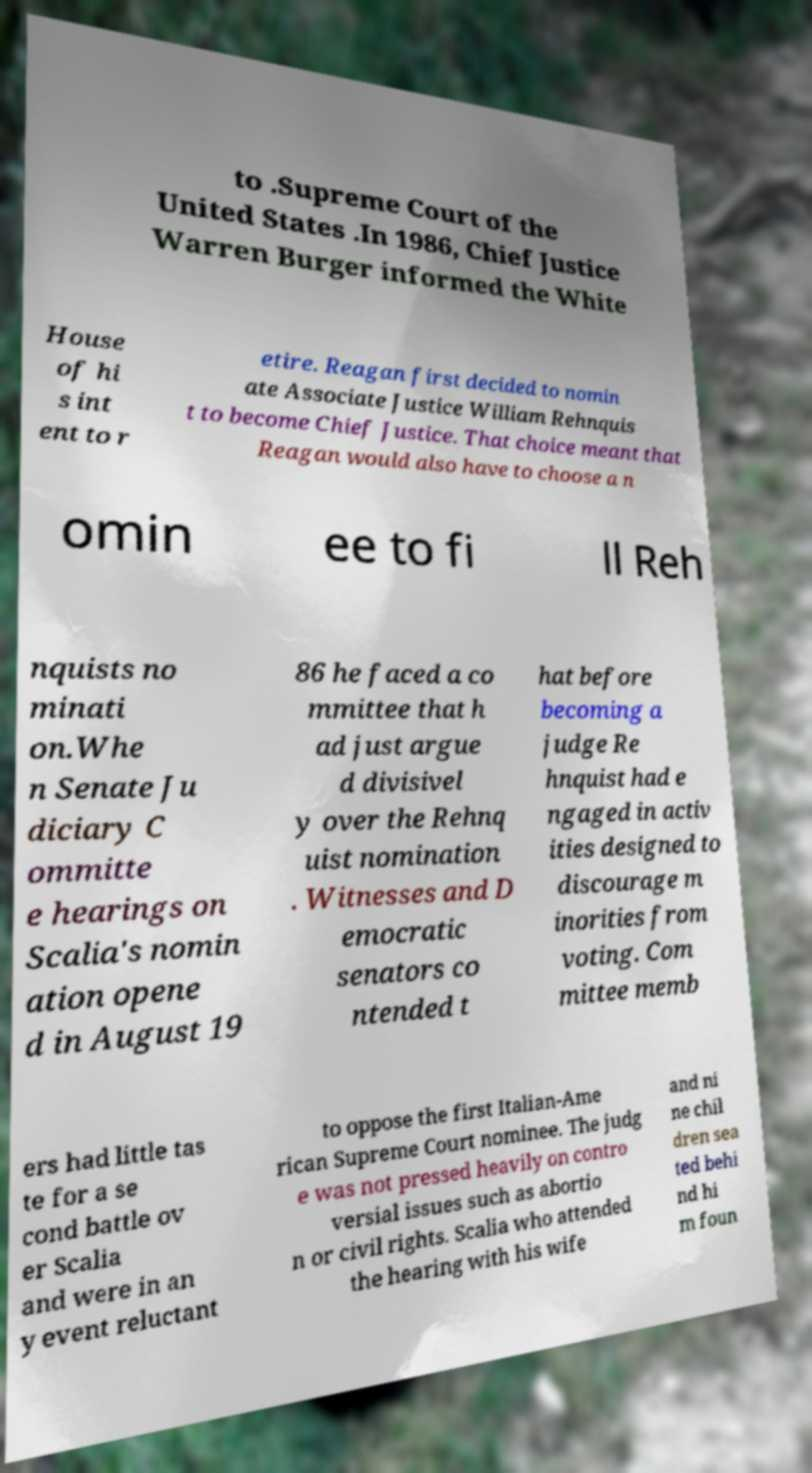What messages or text are displayed in this image? I need them in a readable, typed format. to .Supreme Court of the United States .In 1986, Chief Justice Warren Burger informed the White House of hi s int ent to r etire. Reagan first decided to nomin ate Associate Justice William Rehnquis t to become Chief Justice. That choice meant that Reagan would also have to choose a n omin ee to fi ll Reh nquists no minati on.Whe n Senate Ju diciary C ommitte e hearings on Scalia's nomin ation opene d in August 19 86 he faced a co mmittee that h ad just argue d divisivel y over the Rehnq uist nomination . Witnesses and D emocratic senators co ntended t hat before becoming a judge Re hnquist had e ngaged in activ ities designed to discourage m inorities from voting. Com mittee memb ers had little tas te for a se cond battle ov er Scalia and were in an y event reluctant to oppose the first Italian-Ame rican Supreme Court nominee. The judg e was not pressed heavily on contro versial issues such as abortio n or civil rights. Scalia who attended the hearing with his wife and ni ne chil dren sea ted behi nd hi m foun 